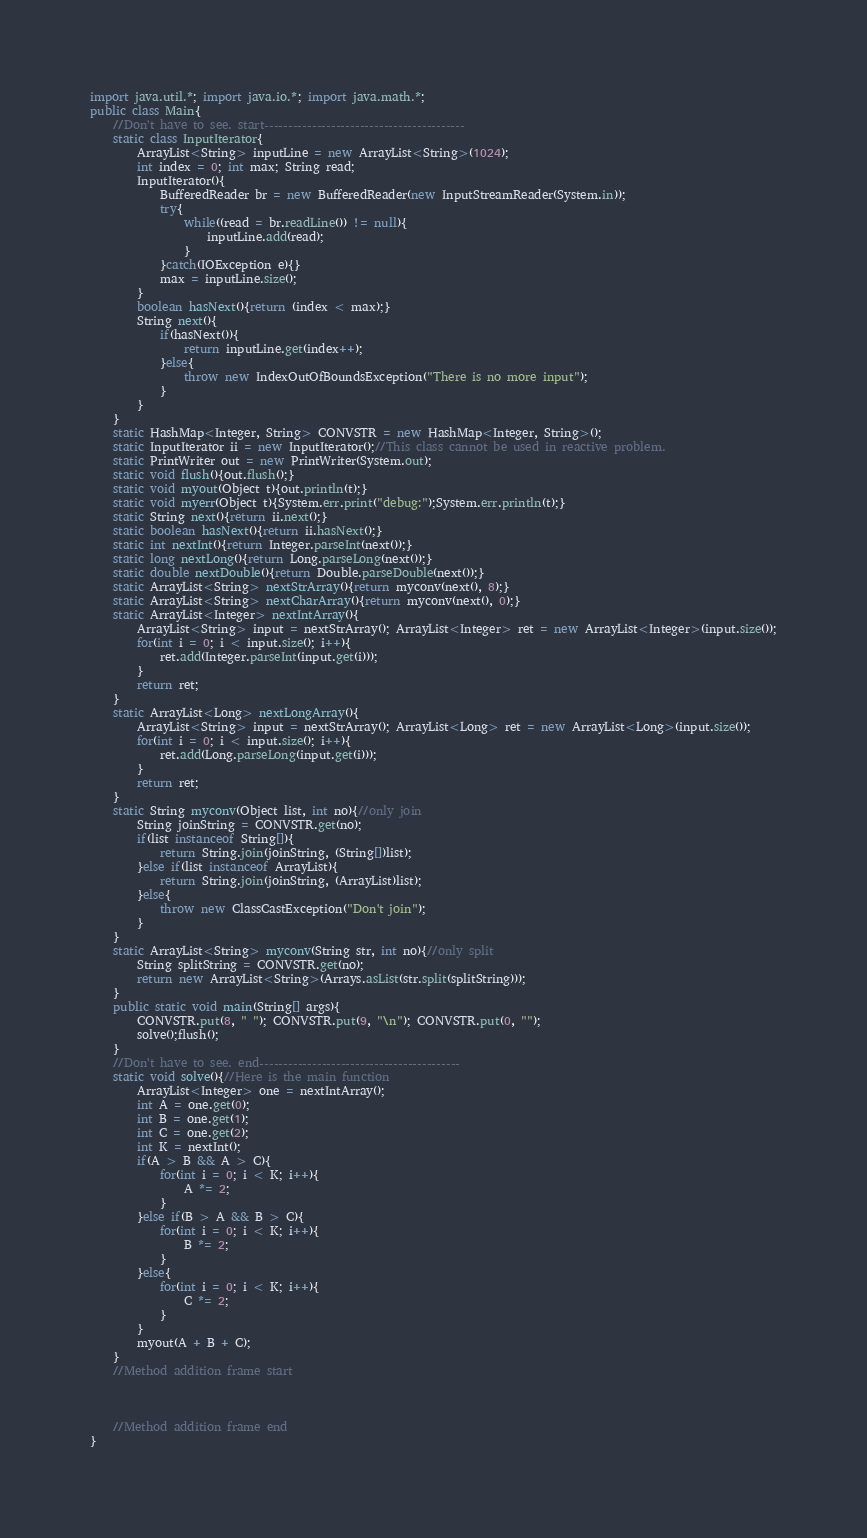Convert code to text. <code><loc_0><loc_0><loc_500><loc_500><_Java_>import java.util.*; import java.io.*; import java.math.*;
public class Main{
	//Don't have to see. start------------------------------------------
	static class InputIterator{
		ArrayList<String> inputLine = new ArrayList<String>(1024);
		int index = 0; int max; String read;
		InputIterator(){
			BufferedReader br = new BufferedReader(new InputStreamReader(System.in));
			try{
				while((read = br.readLine()) != null){
					inputLine.add(read);
				}
			}catch(IOException e){}
			max = inputLine.size();
		}
		boolean hasNext(){return (index < max);}
		String next(){
			if(hasNext()){
				return inputLine.get(index++);
			}else{
				throw new IndexOutOfBoundsException("There is no more input");
			}
		}
	}
	static HashMap<Integer, String> CONVSTR = new HashMap<Integer, String>();
	static InputIterator ii = new InputIterator();//This class cannot be used in reactive problem.
	static PrintWriter out = new PrintWriter(System.out);
	static void flush(){out.flush();}
	static void myout(Object t){out.println(t);}
	static void myerr(Object t){System.err.print("debug:");System.err.println(t);}
	static String next(){return ii.next();}
	static boolean hasNext(){return ii.hasNext();}
	static int nextInt(){return Integer.parseInt(next());}
	static long nextLong(){return Long.parseLong(next());}
	static double nextDouble(){return Double.parseDouble(next());}
	static ArrayList<String> nextStrArray(){return myconv(next(), 8);}
	static ArrayList<String> nextCharArray(){return myconv(next(), 0);}
	static ArrayList<Integer> nextIntArray(){
		ArrayList<String> input = nextStrArray(); ArrayList<Integer> ret = new ArrayList<Integer>(input.size());
		for(int i = 0; i < input.size(); i++){
			ret.add(Integer.parseInt(input.get(i)));
		}
		return ret;
	}
	static ArrayList<Long> nextLongArray(){
		ArrayList<String> input = nextStrArray(); ArrayList<Long> ret = new ArrayList<Long>(input.size());
		for(int i = 0; i < input.size(); i++){
			ret.add(Long.parseLong(input.get(i)));
		}
		return ret;
	}
	static String myconv(Object list, int no){//only join
		String joinString = CONVSTR.get(no);
		if(list instanceof String[]){
			return String.join(joinString, (String[])list);
		}else if(list instanceof ArrayList){
			return String.join(joinString, (ArrayList)list);
		}else{
			throw new ClassCastException("Don't join");
		}
	}
	static ArrayList<String> myconv(String str, int no){//only split
		String splitString = CONVSTR.get(no);
		return new ArrayList<String>(Arrays.asList(str.split(splitString)));
	}
	public static void main(String[] args){
		CONVSTR.put(8, " "); CONVSTR.put(9, "\n"); CONVSTR.put(0, "");
		solve();flush();
	}
	//Don't have to see. end------------------------------------------
	static void solve(){//Here is the main function
		ArrayList<Integer> one = nextIntArray();
		int A = one.get(0);
		int B = one.get(1);
		int C = one.get(2);
		int K = nextInt();
		if(A > B && A > C){
			for(int i = 0; i < K; i++){
				A *= 2;
			}
		}else if(B > A && B > C){
			for(int i = 0; i < K; i++){
				B *= 2;
			}
		}else{
			for(int i = 0; i < K; i++){
				C *= 2;
			}
		}
		myout(A + B + C);
	}
	//Method addition frame start



	//Method addition frame end
}
</code> 